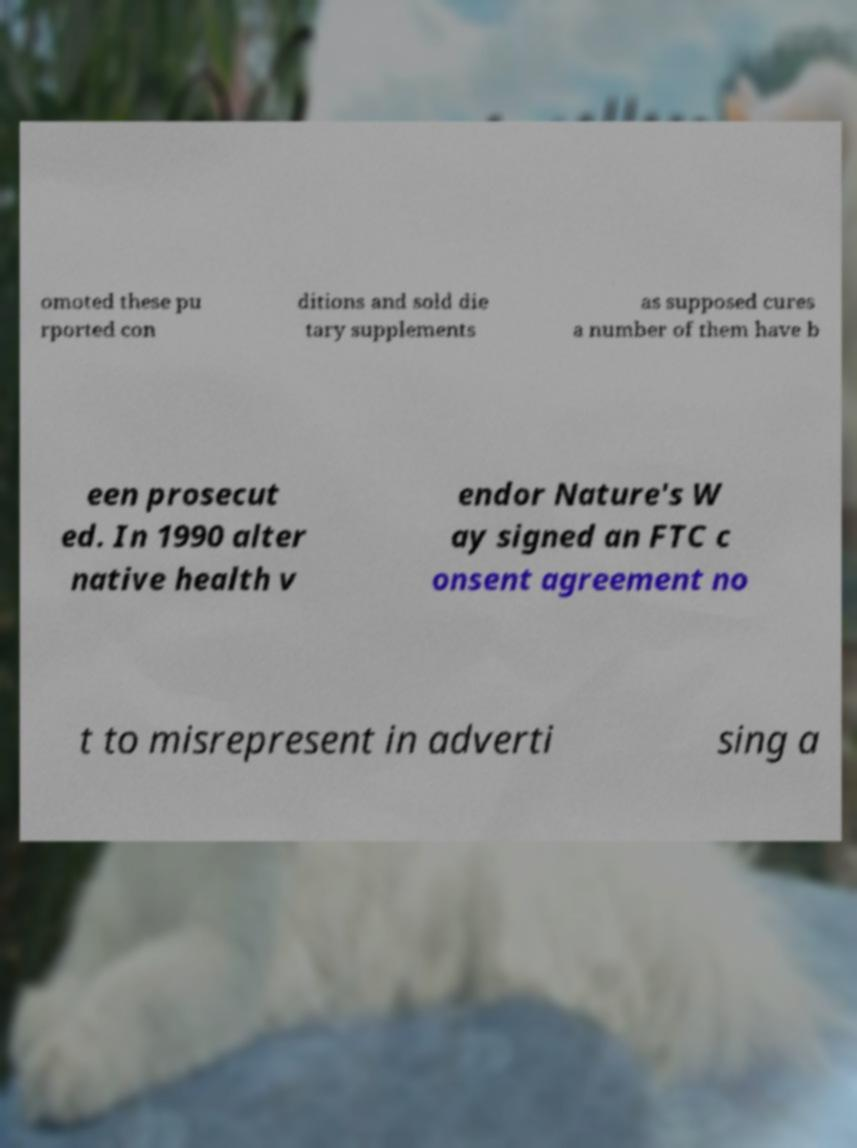Could you assist in decoding the text presented in this image and type it out clearly? omoted these pu rported con ditions and sold die tary supplements as supposed cures a number of them have b een prosecut ed. In 1990 alter native health v endor Nature's W ay signed an FTC c onsent agreement no t to misrepresent in adverti sing a 